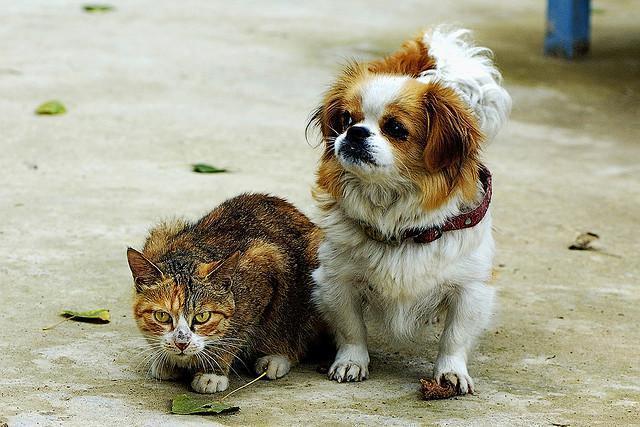How many animals?
Give a very brief answer. 2. 